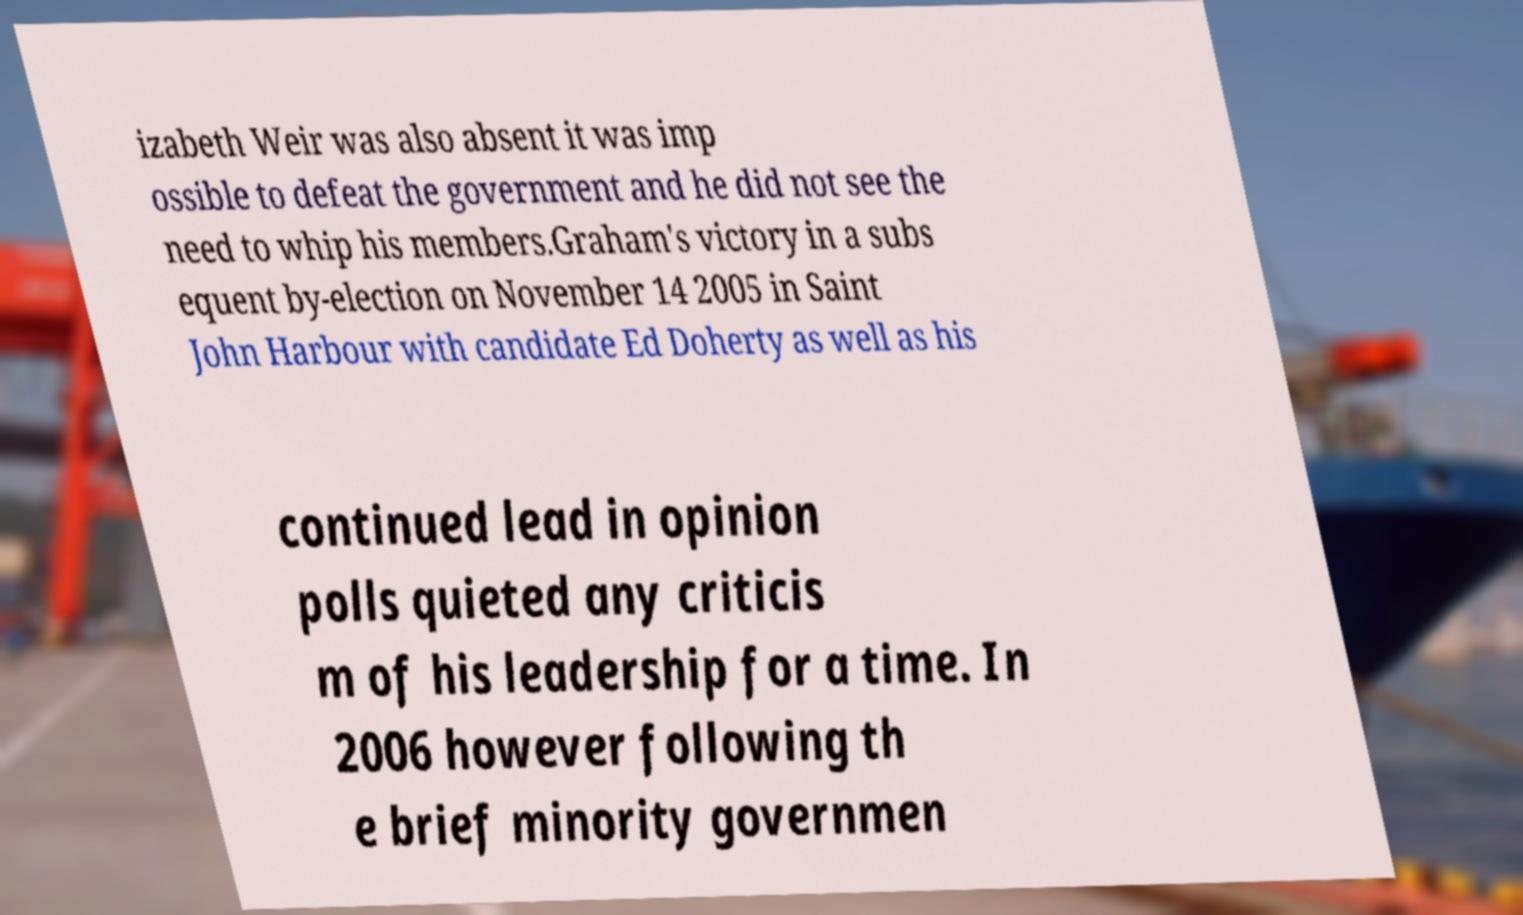Can you accurately transcribe the text from the provided image for me? izabeth Weir was also absent it was imp ossible to defeat the government and he did not see the need to whip his members.Graham's victory in a subs equent by-election on November 14 2005 in Saint John Harbour with candidate Ed Doherty as well as his continued lead in opinion polls quieted any criticis m of his leadership for a time. In 2006 however following th e brief minority governmen 